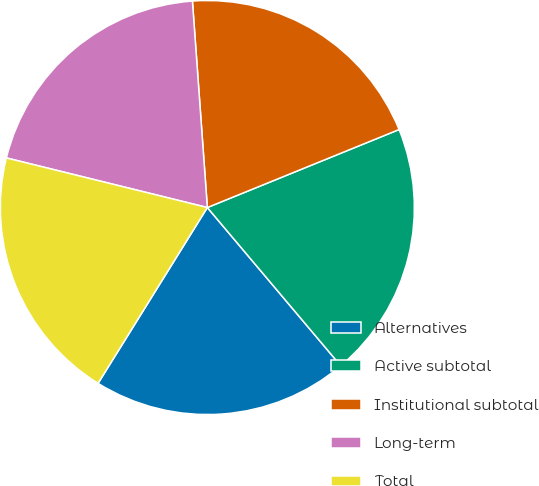Convert chart to OTSL. <chart><loc_0><loc_0><loc_500><loc_500><pie_chart><fcel>Alternatives<fcel>Active subtotal<fcel>Institutional subtotal<fcel>Long-term<fcel>Total<nl><fcel>20.0%<fcel>20.0%<fcel>20.0%<fcel>20.0%<fcel>20.0%<nl></chart> 